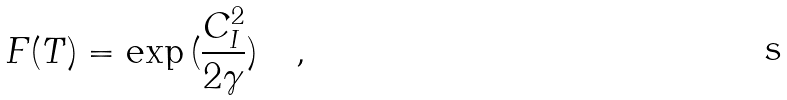<formula> <loc_0><loc_0><loc_500><loc_500>F ( T ) = \exp { ( \frac { C _ { I } ^ { 2 } } { 2 \gamma } ) } \quad ,</formula> 